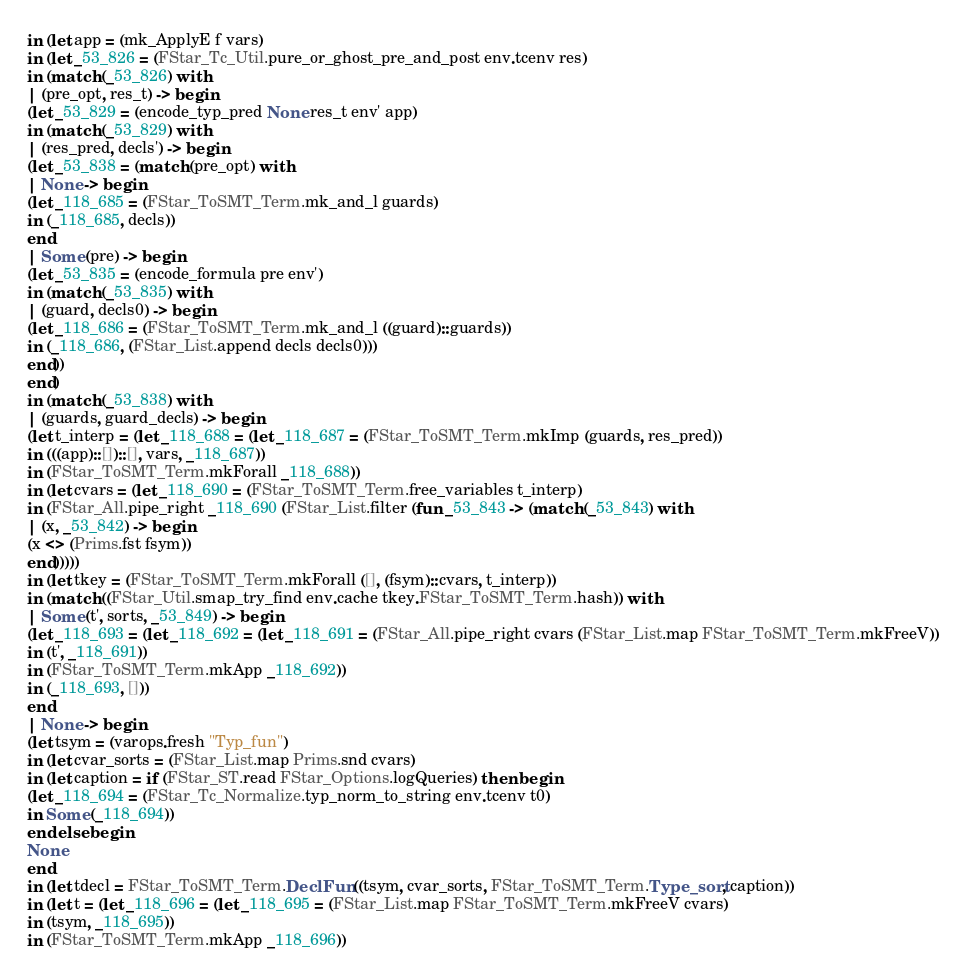Convert code to text. <code><loc_0><loc_0><loc_500><loc_500><_OCaml_>in (let app = (mk_ApplyE f vars)
in (let _53_826 = (FStar_Tc_Util.pure_or_ghost_pre_and_post env.tcenv res)
in (match (_53_826) with
| (pre_opt, res_t) -> begin
(let _53_829 = (encode_typ_pred None res_t env' app)
in (match (_53_829) with
| (res_pred, decls') -> begin
(let _53_838 = (match (pre_opt) with
| None -> begin
(let _118_685 = (FStar_ToSMT_Term.mk_and_l guards)
in (_118_685, decls))
end
| Some (pre) -> begin
(let _53_835 = (encode_formula pre env')
in (match (_53_835) with
| (guard, decls0) -> begin
(let _118_686 = (FStar_ToSMT_Term.mk_and_l ((guard)::guards))
in (_118_686, (FStar_List.append decls decls0)))
end))
end)
in (match (_53_838) with
| (guards, guard_decls) -> begin
(let t_interp = (let _118_688 = (let _118_687 = (FStar_ToSMT_Term.mkImp (guards, res_pred))
in (((app)::[])::[], vars, _118_687))
in (FStar_ToSMT_Term.mkForall _118_688))
in (let cvars = (let _118_690 = (FStar_ToSMT_Term.free_variables t_interp)
in (FStar_All.pipe_right _118_690 (FStar_List.filter (fun _53_843 -> (match (_53_843) with
| (x, _53_842) -> begin
(x <> (Prims.fst fsym))
end)))))
in (let tkey = (FStar_ToSMT_Term.mkForall ([], (fsym)::cvars, t_interp))
in (match ((FStar_Util.smap_try_find env.cache tkey.FStar_ToSMT_Term.hash)) with
| Some (t', sorts, _53_849) -> begin
(let _118_693 = (let _118_692 = (let _118_691 = (FStar_All.pipe_right cvars (FStar_List.map FStar_ToSMT_Term.mkFreeV))
in (t', _118_691))
in (FStar_ToSMT_Term.mkApp _118_692))
in (_118_693, []))
end
| None -> begin
(let tsym = (varops.fresh "Typ_fun")
in (let cvar_sorts = (FStar_List.map Prims.snd cvars)
in (let caption = if (FStar_ST.read FStar_Options.logQueries) then begin
(let _118_694 = (FStar_Tc_Normalize.typ_norm_to_string env.tcenv t0)
in Some (_118_694))
end else begin
None
end
in (let tdecl = FStar_ToSMT_Term.DeclFun ((tsym, cvar_sorts, FStar_ToSMT_Term.Type_sort, caption))
in (let t = (let _118_696 = (let _118_695 = (FStar_List.map FStar_ToSMT_Term.mkFreeV cvars)
in (tsym, _118_695))
in (FStar_ToSMT_Term.mkApp _118_696))</code> 